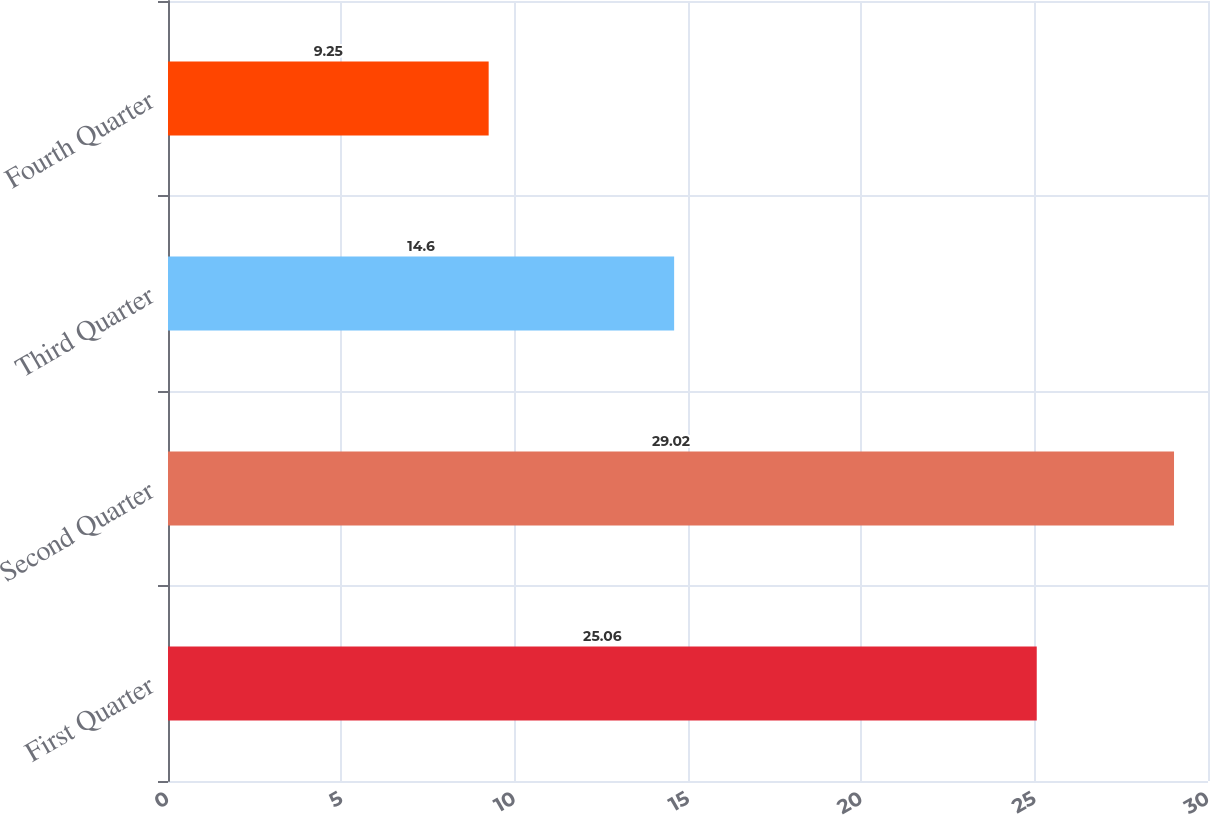Convert chart to OTSL. <chart><loc_0><loc_0><loc_500><loc_500><bar_chart><fcel>First Quarter<fcel>Second Quarter<fcel>Third Quarter<fcel>Fourth Quarter<nl><fcel>25.06<fcel>29.02<fcel>14.6<fcel>9.25<nl></chart> 